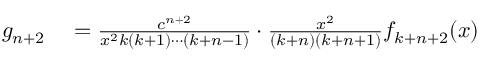<formula> <loc_0><loc_0><loc_500><loc_500>\begin{array} { r l } { g _ { n + 2 } } & = { \frac { c ^ { n + 2 } } { x ^ { 2 } k ( k + 1 ) \cdots ( k + n - 1 ) } } \cdot { \frac { x ^ { 2 } } { ( k + n ) ( k + n + 1 ) } } f _ { k + n + 2 } ( x ) } \end{array}</formula> 